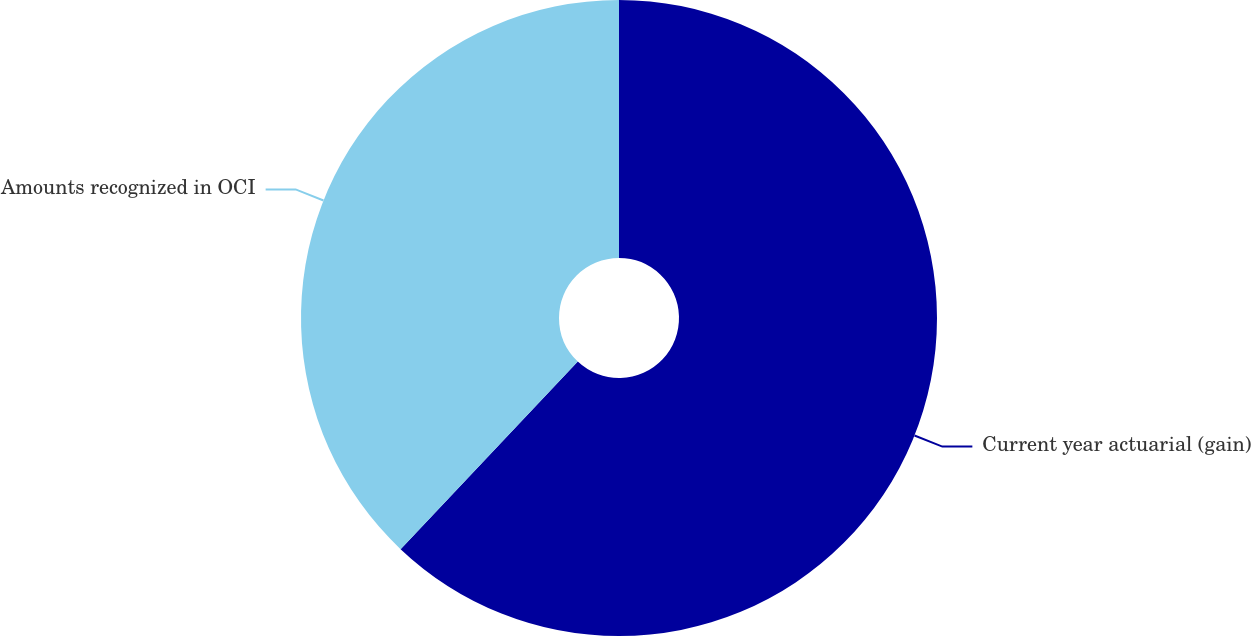Convert chart. <chart><loc_0><loc_0><loc_500><loc_500><pie_chart><fcel>Current year actuarial (gain)<fcel>Amounts recognized in OCI<nl><fcel>62.05%<fcel>37.95%<nl></chart> 